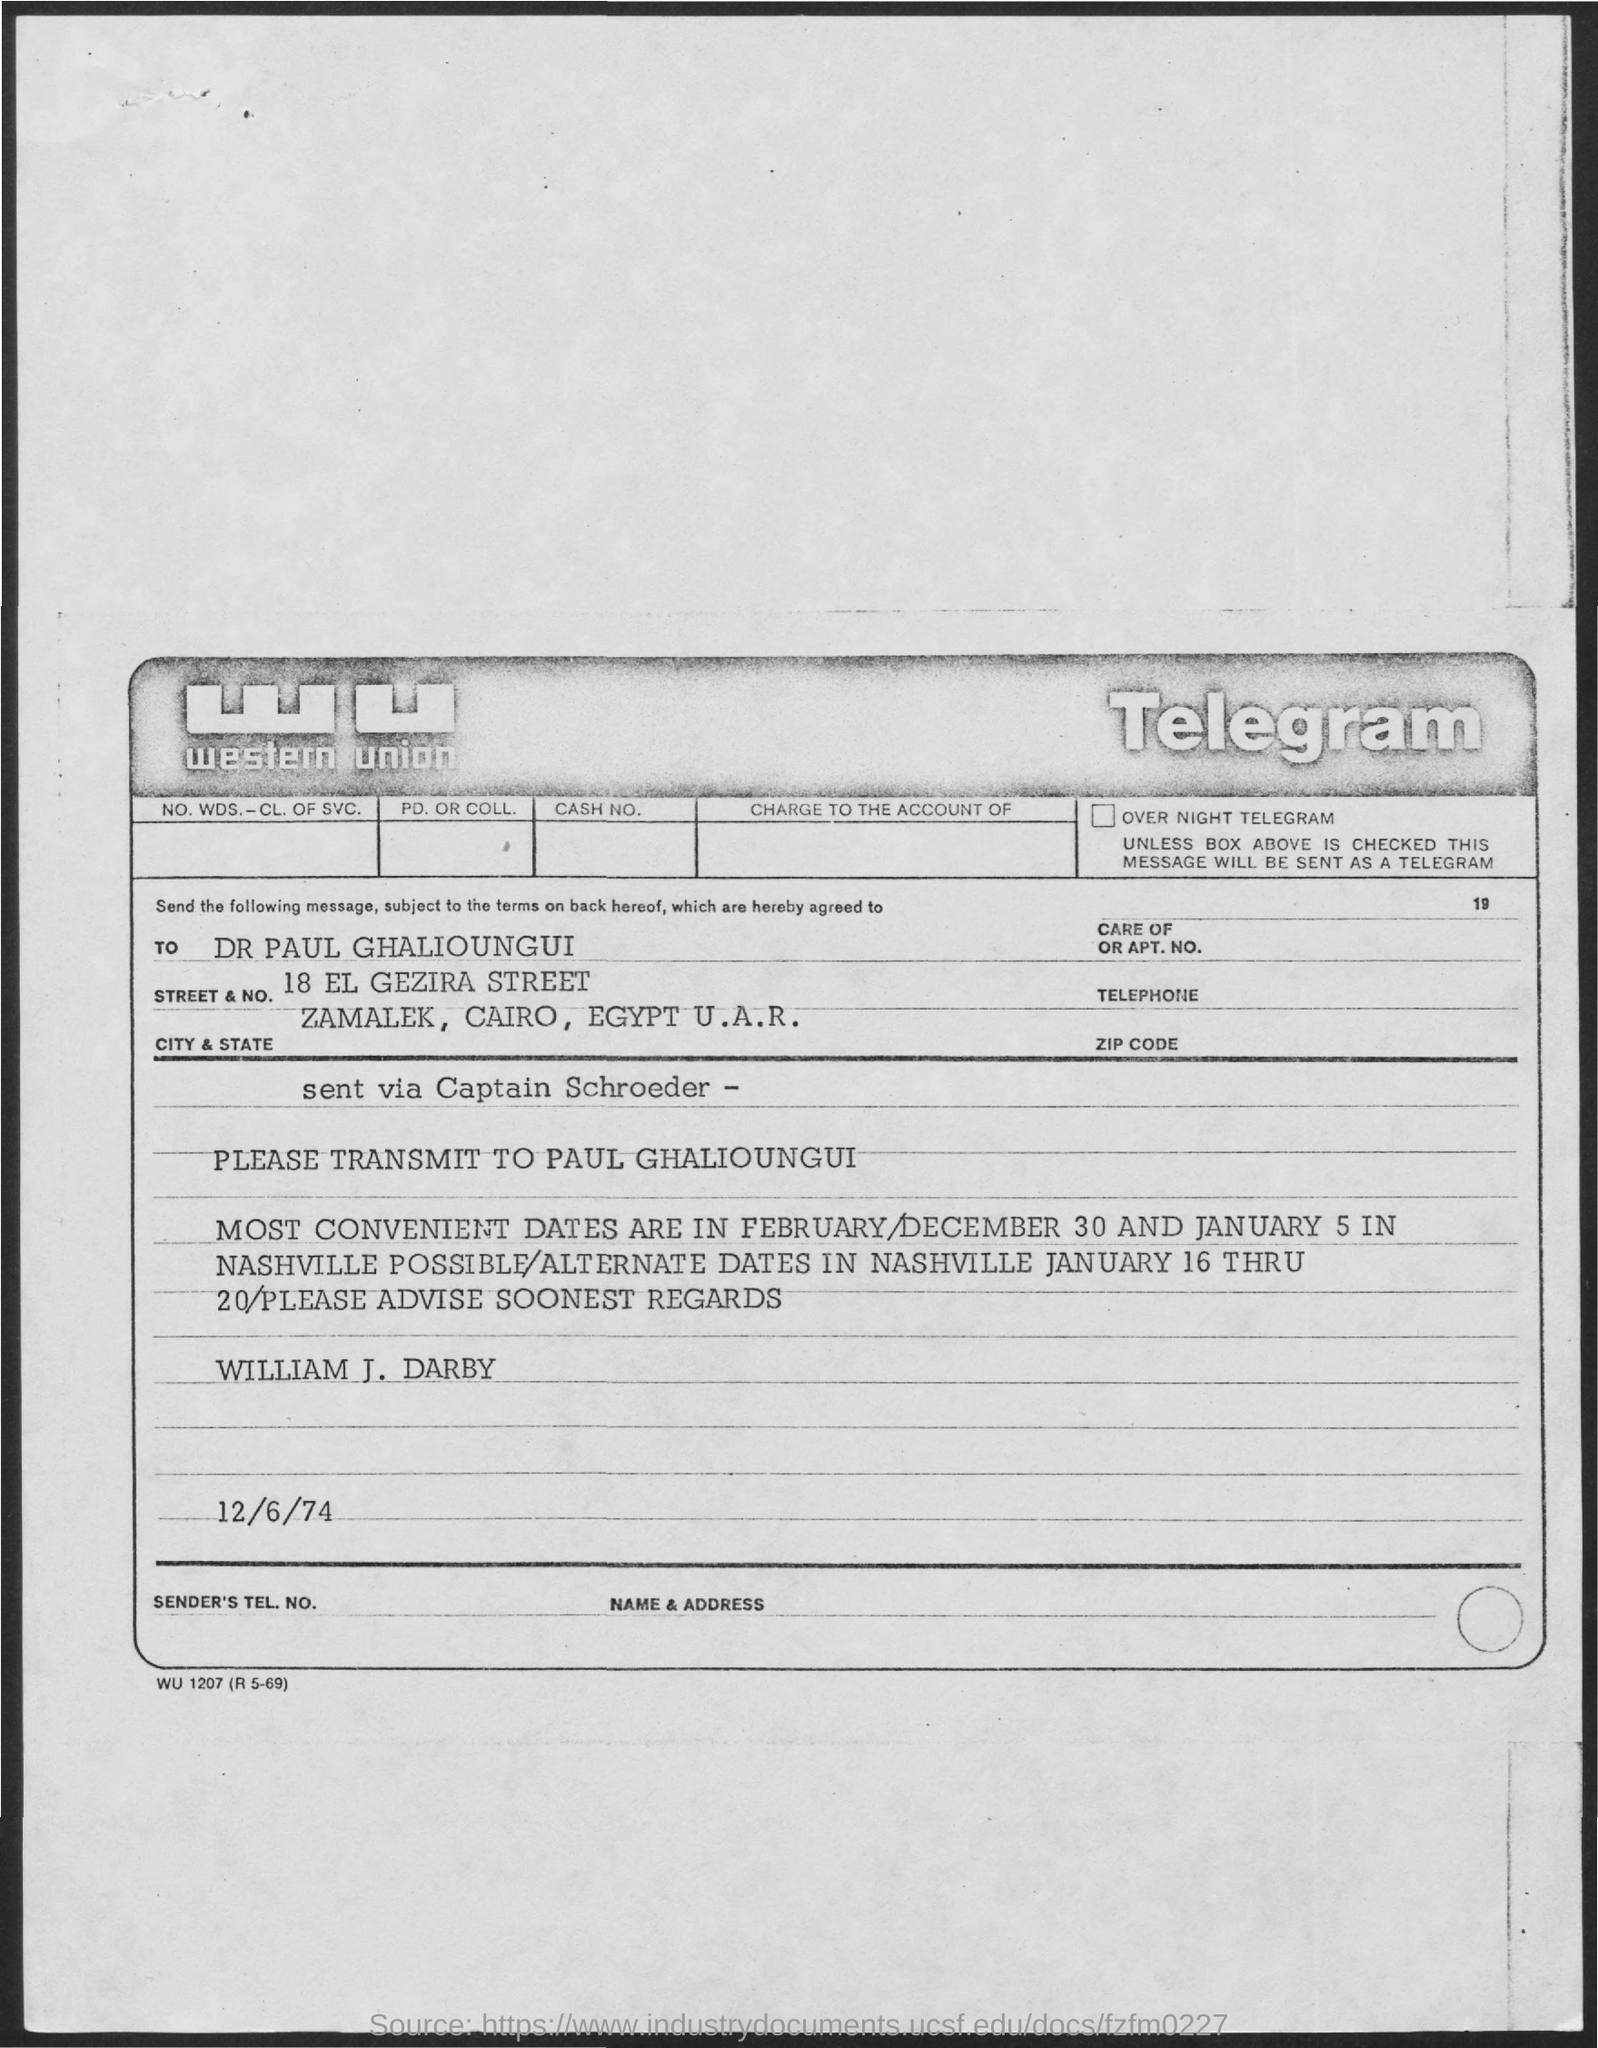What is the Street & No.?
Provide a short and direct response. 18 EL GEZIRA STREET. What is the City and State?
Offer a very short reply. ZAMALEK, CAIRO, EGYPT U.A.R. Which are the most convenient dates?
Your answer should be very brief. February/December 30 and January 5. Who is this telegram from?
Give a very brief answer. William J. Darby. What is the date of the Telegram?
Keep it short and to the point. 12/6/74. 